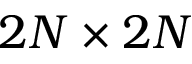<formula> <loc_0><loc_0><loc_500><loc_500>2 N \times 2 N</formula> 